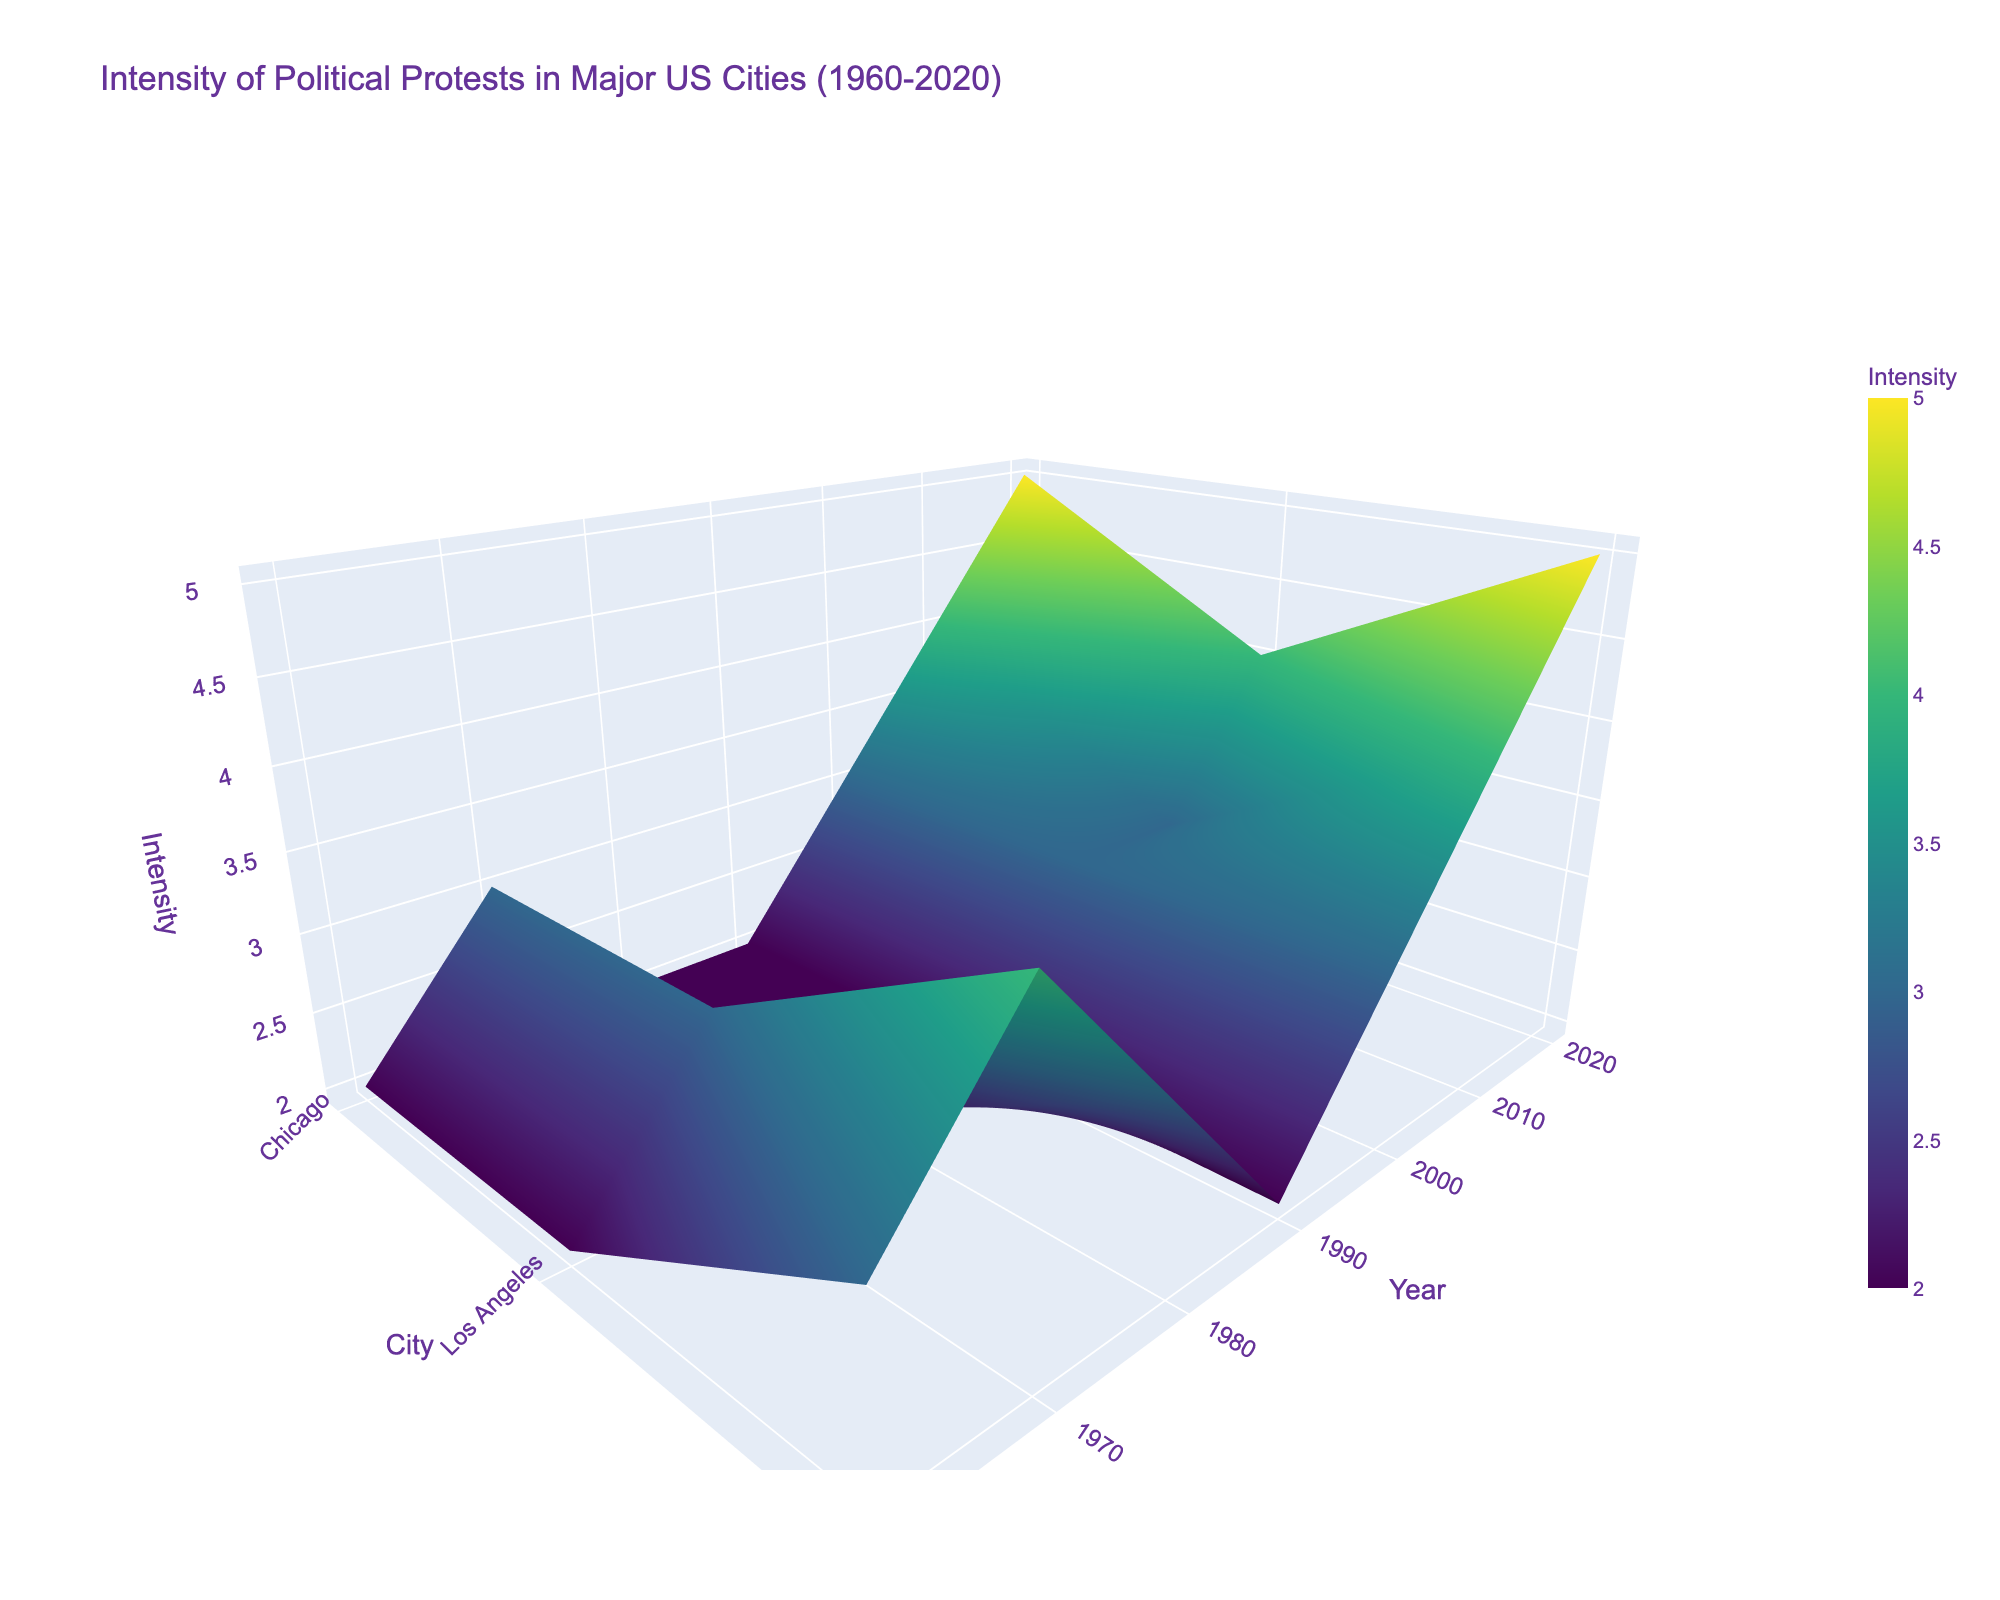What is the title of the figure? The title of the figure is typically displayed at the top of the plot. By viewing the top section, you can read the full title directly.
Answer: Intensity of Political Protests in Major US Cities (1960-2020) Which city has the highest intensity of political protests in 2020? The z-axis represents the intensity, the y-axis represents the year, and the x-axis represents the city. Locating the year 2020 on the y-axis and checking the corresponding intensities for each city will show New York has the highest intensity.
Answer: New York What trend do you observe in the intensity of protests in New York over the decades? By following the surface plot along the x-axis for New York and observing the height across different years, we see a general increase in intensity from 1960 to 2020.
Answer: Increasing In which decade did Chicago have the highest intensity of political protests? Locate the line on the surface plot that corresponds to Chicago and compare the z-axis (intensity) for each decade. The highest z-values are observed in 2020.
Answer: 2020 How does the intensity of protests in Los Angeles in 1980 compare to New York in the same year? Find the point corresponding to 1980 on the y-axis and compare the z-axis (intensity) values for Los Angeles and New York. New York had higher intensity than Los Angeles.
Answer: New York had higher intensity Which city shows the most significant increase in protest intensity from 2010 to 2020? Locate the years 2010 and 2020 on the y-axis for each city and compare the differences in z-values. New York shows the most significant increase.
Answer: New York What are the intensity levels of political protests in Chicago in the years 1970, 1980, and 1990? Locate these specific years on the y-axis for Chicago and read the corresponding z-values (intensities). They are 3 in 1970, 2 in 1980, and 2 in 1990.
Answer: 3, 2, and 2 Which city had the lowest protest intensity in 1960? For the year 1960 on the y-axis, evaluate the z-values for each city. Los Angeles has the lowest intensity.
Answer: Los Angeles What is the intensity value of political protests in New York in 2000? Find the 2000 point on the y-axis and check the z-value for New York. The intensity is 3.
Answer: 3 How does the overall trend of protest intensity in Los Angeles compare to that in Chicago from 1960 to 2020? By comparing the surface plots for Los Angeles and Chicago along the years from 1960 to 2020, both increase overall, but Chicago’s trend is more consistent, while Los Angeles shows more fluctuations.
Answer: Both increased, but Chicago's trend is more consistent 